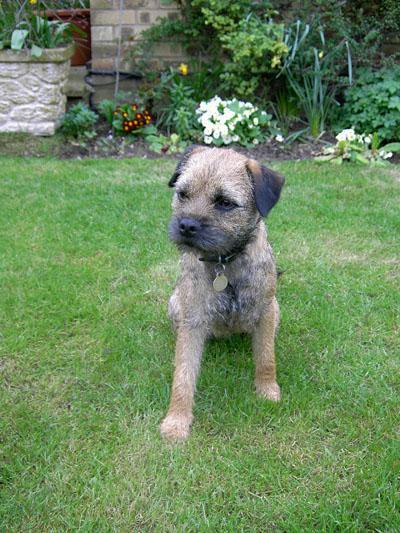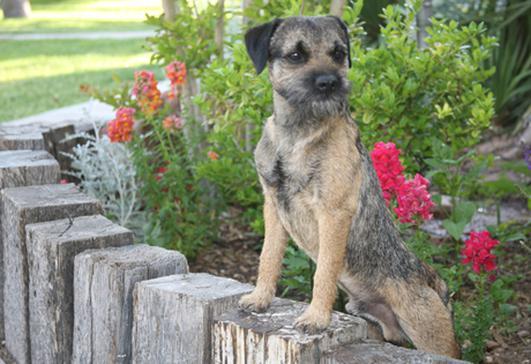The first image is the image on the left, the second image is the image on the right. Examine the images to the left and right. Is the description "The left image shows one dog with a rightward turned body standing on all fours, and the right image shows a dog looking leftward." accurate? Answer yes or no. No. The first image is the image on the left, the second image is the image on the right. Analyze the images presented: Is the assertion "The left and right image contains the same number of dogs with at least one laying down." valid? Answer yes or no. No. 